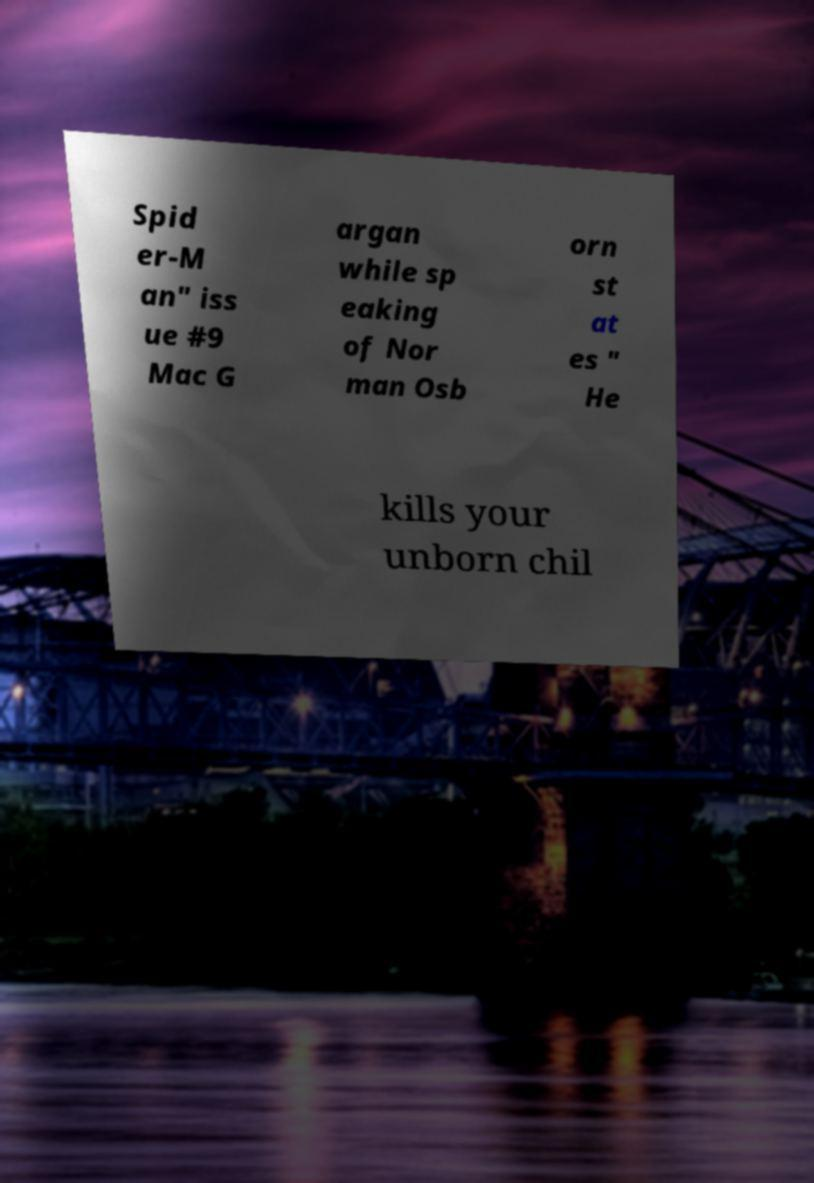Please identify and transcribe the text found in this image. Spid er-M an" iss ue #9 Mac G argan while sp eaking of Nor man Osb orn st at es " He kills your unborn chil 